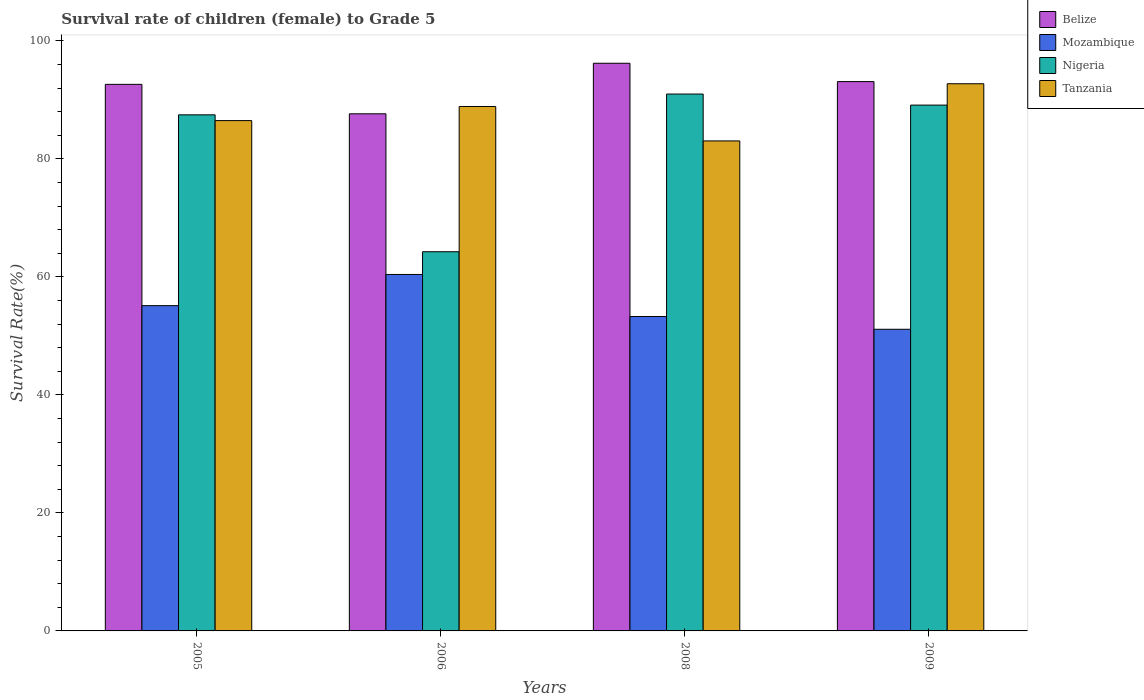How many different coloured bars are there?
Keep it short and to the point. 4. How many groups of bars are there?
Offer a terse response. 4. Are the number of bars per tick equal to the number of legend labels?
Provide a succinct answer. Yes. Are the number of bars on each tick of the X-axis equal?
Provide a succinct answer. Yes. What is the label of the 1st group of bars from the left?
Ensure brevity in your answer.  2005. What is the survival rate of female children to grade 5 in Mozambique in 2006?
Provide a short and direct response. 60.4. Across all years, what is the maximum survival rate of female children to grade 5 in Belize?
Your response must be concise. 96.19. Across all years, what is the minimum survival rate of female children to grade 5 in Belize?
Make the answer very short. 87.63. What is the total survival rate of female children to grade 5 in Mozambique in the graph?
Your answer should be very brief. 219.91. What is the difference between the survival rate of female children to grade 5 in Belize in 2006 and that in 2008?
Offer a very short reply. -8.56. What is the difference between the survival rate of female children to grade 5 in Mozambique in 2008 and the survival rate of female children to grade 5 in Belize in 2009?
Offer a very short reply. -39.81. What is the average survival rate of female children to grade 5 in Mozambique per year?
Offer a terse response. 54.98. In the year 2006, what is the difference between the survival rate of female children to grade 5 in Belize and survival rate of female children to grade 5 in Nigeria?
Offer a terse response. 23.38. What is the ratio of the survival rate of female children to grade 5 in Belize in 2006 to that in 2009?
Give a very brief answer. 0.94. Is the survival rate of female children to grade 5 in Tanzania in 2008 less than that in 2009?
Offer a terse response. Yes. What is the difference between the highest and the second highest survival rate of female children to grade 5 in Nigeria?
Give a very brief answer. 1.87. What is the difference between the highest and the lowest survival rate of female children to grade 5 in Tanzania?
Ensure brevity in your answer.  9.69. Is the sum of the survival rate of female children to grade 5 in Mozambique in 2005 and 2006 greater than the maximum survival rate of female children to grade 5 in Tanzania across all years?
Your answer should be very brief. Yes. Is it the case that in every year, the sum of the survival rate of female children to grade 5 in Mozambique and survival rate of female children to grade 5 in Tanzania is greater than the sum of survival rate of female children to grade 5 in Belize and survival rate of female children to grade 5 in Nigeria?
Your response must be concise. No. What does the 4th bar from the left in 2006 represents?
Provide a succinct answer. Tanzania. What does the 2nd bar from the right in 2008 represents?
Your answer should be compact. Nigeria. Are all the bars in the graph horizontal?
Keep it short and to the point. No. How many years are there in the graph?
Your answer should be very brief. 4. What is the difference between two consecutive major ticks on the Y-axis?
Make the answer very short. 20. Are the values on the major ticks of Y-axis written in scientific E-notation?
Offer a very short reply. No. Does the graph contain any zero values?
Your response must be concise. No. Does the graph contain grids?
Offer a terse response. No. Where does the legend appear in the graph?
Provide a succinct answer. Top right. How many legend labels are there?
Your response must be concise. 4. What is the title of the graph?
Give a very brief answer. Survival rate of children (female) to Grade 5. What is the label or title of the X-axis?
Your answer should be very brief. Years. What is the label or title of the Y-axis?
Your response must be concise. Survival Rate(%). What is the Survival Rate(%) of Belize in 2005?
Your answer should be very brief. 92.62. What is the Survival Rate(%) in Mozambique in 2005?
Your answer should be compact. 55.12. What is the Survival Rate(%) in Nigeria in 2005?
Provide a short and direct response. 87.45. What is the Survival Rate(%) of Tanzania in 2005?
Make the answer very short. 86.48. What is the Survival Rate(%) in Belize in 2006?
Make the answer very short. 87.63. What is the Survival Rate(%) of Mozambique in 2006?
Your answer should be compact. 60.4. What is the Survival Rate(%) of Nigeria in 2006?
Your answer should be compact. 64.25. What is the Survival Rate(%) in Tanzania in 2006?
Give a very brief answer. 88.87. What is the Survival Rate(%) of Belize in 2008?
Your answer should be compact. 96.19. What is the Survival Rate(%) in Mozambique in 2008?
Keep it short and to the point. 53.28. What is the Survival Rate(%) of Nigeria in 2008?
Make the answer very short. 90.98. What is the Survival Rate(%) of Tanzania in 2008?
Provide a short and direct response. 83.03. What is the Survival Rate(%) of Belize in 2009?
Make the answer very short. 93.09. What is the Survival Rate(%) in Mozambique in 2009?
Offer a very short reply. 51.12. What is the Survival Rate(%) in Nigeria in 2009?
Offer a very short reply. 89.1. What is the Survival Rate(%) in Tanzania in 2009?
Offer a terse response. 92.72. Across all years, what is the maximum Survival Rate(%) of Belize?
Provide a succinct answer. 96.19. Across all years, what is the maximum Survival Rate(%) of Mozambique?
Give a very brief answer. 60.4. Across all years, what is the maximum Survival Rate(%) of Nigeria?
Provide a short and direct response. 90.98. Across all years, what is the maximum Survival Rate(%) of Tanzania?
Keep it short and to the point. 92.72. Across all years, what is the minimum Survival Rate(%) of Belize?
Ensure brevity in your answer.  87.63. Across all years, what is the minimum Survival Rate(%) of Mozambique?
Give a very brief answer. 51.12. Across all years, what is the minimum Survival Rate(%) in Nigeria?
Offer a terse response. 64.25. Across all years, what is the minimum Survival Rate(%) of Tanzania?
Give a very brief answer. 83.03. What is the total Survival Rate(%) of Belize in the graph?
Offer a terse response. 369.53. What is the total Survival Rate(%) in Mozambique in the graph?
Provide a succinct answer. 219.91. What is the total Survival Rate(%) in Nigeria in the graph?
Provide a short and direct response. 331.79. What is the total Survival Rate(%) in Tanzania in the graph?
Your answer should be compact. 351.1. What is the difference between the Survival Rate(%) in Belize in 2005 and that in 2006?
Offer a terse response. 4.99. What is the difference between the Survival Rate(%) in Mozambique in 2005 and that in 2006?
Make the answer very short. -5.28. What is the difference between the Survival Rate(%) in Nigeria in 2005 and that in 2006?
Your answer should be compact. 23.2. What is the difference between the Survival Rate(%) in Tanzania in 2005 and that in 2006?
Your response must be concise. -2.39. What is the difference between the Survival Rate(%) in Belize in 2005 and that in 2008?
Offer a very short reply. -3.58. What is the difference between the Survival Rate(%) of Mozambique in 2005 and that in 2008?
Your answer should be very brief. 1.84. What is the difference between the Survival Rate(%) of Nigeria in 2005 and that in 2008?
Give a very brief answer. -3.52. What is the difference between the Survival Rate(%) in Tanzania in 2005 and that in 2008?
Offer a terse response. 3.44. What is the difference between the Survival Rate(%) in Belize in 2005 and that in 2009?
Offer a very short reply. -0.47. What is the difference between the Survival Rate(%) of Mozambique in 2005 and that in 2009?
Your answer should be very brief. 4. What is the difference between the Survival Rate(%) in Nigeria in 2005 and that in 2009?
Ensure brevity in your answer.  -1.65. What is the difference between the Survival Rate(%) of Tanzania in 2005 and that in 2009?
Offer a terse response. -6.25. What is the difference between the Survival Rate(%) in Belize in 2006 and that in 2008?
Keep it short and to the point. -8.56. What is the difference between the Survival Rate(%) in Mozambique in 2006 and that in 2008?
Offer a very short reply. 7.13. What is the difference between the Survival Rate(%) of Nigeria in 2006 and that in 2008?
Make the answer very short. -26.72. What is the difference between the Survival Rate(%) of Tanzania in 2006 and that in 2008?
Your answer should be compact. 5.83. What is the difference between the Survival Rate(%) of Belize in 2006 and that in 2009?
Offer a very short reply. -5.46. What is the difference between the Survival Rate(%) in Mozambique in 2006 and that in 2009?
Keep it short and to the point. 9.29. What is the difference between the Survival Rate(%) of Nigeria in 2006 and that in 2009?
Make the answer very short. -24.85. What is the difference between the Survival Rate(%) of Tanzania in 2006 and that in 2009?
Your response must be concise. -3.86. What is the difference between the Survival Rate(%) in Belize in 2008 and that in 2009?
Offer a terse response. 3.11. What is the difference between the Survival Rate(%) in Mozambique in 2008 and that in 2009?
Your answer should be very brief. 2.16. What is the difference between the Survival Rate(%) of Nigeria in 2008 and that in 2009?
Offer a very short reply. 1.87. What is the difference between the Survival Rate(%) of Tanzania in 2008 and that in 2009?
Give a very brief answer. -9.69. What is the difference between the Survival Rate(%) in Belize in 2005 and the Survival Rate(%) in Mozambique in 2006?
Offer a very short reply. 32.22. What is the difference between the Survival Rate(%) of Belize in 2005 and the Survival Rate(%) of Nigeria in 2006?
Provide a succinct answer. 28.37. What is the difference between the Survival Rate(%) in Belize in 2005 and the Survival Rate(%) in Tanzania in 2006?
Offer a very short reply. 3.75. What is the difference between the Survival Rate(%) in Mozambique in 2005 and the Survival Rate(%) in Nigeria in 2006?
Give a very brief answer. -9.13. What is the difference between the Survival Rate(%) in Mozambique in 2005 and the Survival Rate(%) in Tanzania in 2006?
Give a very brief answer. -33.75. What is the difference between the Survival Rate(%) in Nigeria in 2005 and the Survival Rate(%) in Tanzania in 2006?
Offer a very short reply. -1.41. What is the difference between the Survival Rate(%) of Belize in 2005 and the Survival Rate(%) of Mozambique in 2008?
Provide a succinct answer. 39.34. What is the difference between the Survival Rate(%) in Belize in 2005 and the Survival Rate(%) in Nigeria in 2008?
Offer a very short reply. 1.64. What is the difference between the Survival Rate(%) of Belize in 2005 and the Survival Rate(%) of Tanzania in 2008?
Offer a very short reply. 9.59. What is the difference between the Survival Rate(%) of Mozambique in 2005 and the Survival Rate(%) of Nigeria in 2008?
Ensure brevity in your answer.  -35.86. What is the difference between the Survival Rate(%) in Mozambique in 2005 and the Survival Rate(%) in Tanzania in 2008?
Your answer should be very brief. -27.91. What is the difference between the Survival Rate(%) of Nigeria in 2005 and the Survival Rate(%) of Tanzania in 2008?
Your answer should be compact. 4.42. What is the difference between the Survival Rate(%) of Belize in 2005 and the Survival Rate(%) of Mozambique in 2009?
Your answer should be very brief. 41.5. What is the difference between the Survival Rate(%) in Belize in 2005 and the Survival Rate(%) in Nigeria in 2009?
Your response must be concise. 3.52. What is the difference between the Survival Rate(%) in Belize in 2005 and the Survival Rate(%) in Tanzania in 2009?
Your response must be concise. -0.1. What is the difference between the Survival Rate(%) of Mozambique in 2005 and the Survival Rate(%) of Nigeria in 2009?
Offer a terse response. -33.98. What is the difference between the Survival Rate(%) in Mozambique in 2005 and the Survival Rate(%) in Tanzania in 2009?
Make the answer very short. -37.6. What is the difference between the Survival Rate(%) in Nigeria in 2005 and the Survival Rate(%) in Tanzania in 2009?
Make the answer very short. -5.27. What is the difference between the Survival Rate(%) in Belize in 2006 and the Survival Rate(%) in Mozambique in 2008?
Keep it short and to the point. 34.35. What is the difference between the Survival Rate(%) in Belize in 2006 and the Survival Rate(%) in Nigeria in 2008?
Provide a succinct answer. -3.35. What is the difference between the Survival Rate(%) in Belize in 2006 and the Survival Rate(%) in Tanzania in 2008?
Offer a very short reply. 4.6. What is the difference between the Survival Rate(%) in Mozambique in 2006 and the Survival Rate(%) in Nigeria in 2008?
Provide a short and direct response. -30.57. What is the difference between the Survival Rate(%) of Mozambique in 2006 and the Survival Rate(%) of Tanzania in 2008?
Your answer should be compact. -22.63. What is the difference between the Survival Rate(%) in Nigeria in 2006 and the Survival Rate(%) in Tanzania in 2008?
Keep it short and to the point. -18.78. What is the difference between the Survival Rate(%) in Belize in 2006 and the Survival Rate(%) in Mozambique in 2009?
Offer a very short reply. 36.51. What is the difference between the Survival Rate(%) of Belize in 2006 and the Survival Rate(%) of Nigeria in 2009?
Ensure brevity in your answer.  -1.47. What is the difference between the Survival Rate(%) of Belize in 2006 and the Survival Rate(%) of Tanzania in 2009?
Offer a very short reply. -5.09. What is the difference between the Survival Rate(%) of Mozambique in 2006 and the Survival Rate(%) of Nigeria in 2009?
Ensure brevity in your answer.  -28.7. What is the difference between the Survival Rate(%) of Mozambique in 2006 and the Survival Rate(%) of Tanzania in 2009?
Ensure brevity in your answer.  -32.32. What is the difference between the Survival Rate(%) of Nigeria in 2006 and the Survival Rate(%) of Tanzania in 2009?
Offer a very short reply. -28.47. What is the difference between the Survival Rate(%) in Belize in 2008 and the Survival Rate(%) in Mozambique in 2009?
Make the answer very short. 45.08. What is the difference between the Survival Rate(%) in Belize in 2008 and the Survival Rate(%) in Nigeria in 2009?
Offer a terse response. 7.09. What is the difference between the Survival Rate(%) of Belize in 2008 and the Survival Rate(%) of Tanzania in 2009?
Your response must be concise. 3.47. What is the difference between the Survival Rate(%) of Mozambique in 2008 and the Survival Rate(%) of Nigeria in 2009?
Give a very brief answer. -35.83. What is the difference between the Survival Rate(%) in Mozambique in 2008 and the Survival Rate(%) in Tanzania in 2009?
Offer a terse response. -39.45. What is the difference between the Survival Rate(%) in Nigeria in 2008 and the Survival Rate(%) in Tanzania in 2009?
Offer a terse response. -1.75. What is the average Survival Rate(%) in Belize per year?
Offer a terse response. 92.38. What is the average Survival Rate(%) of Mozambique per year?
Your response must be concise. 54.98. What is the average Survival Rate(%) of Nigeria per year?
Make the answer very short. 82.95. What is the average Survival Rate(%) of Tanzania per year?
Keep it short and to the point. 87.78. In the year 2005, what is the difference between the Survival Rate(%) of Belize and Survival Rate(%) of Mozambique?
Your answer should be compact. 37.5. In the year 2005, what is the difference between the Survival Rate(%) of Belize and Survival Rate(%) of Nigeria?
Offer a very short reply. 5.17. In the year 2005, what is the difference between the Survival Rate(%) in Belize and Survival Rate(%) in Tanzania?
Ensure brevity in your answer.  6.14. In the year 2005, what is the difference between the Survival Rate(%) in Mozambique and Survival Rate(%) in Nigeria?
Provide a succinct answer. -32.33. In the year 2005, what is the difference between the Survival Rate(%) in Mozambique and Survival Rate(%) in Tanzania?
Give a very brief answer. -31.36. In the year 2005, what is the difference between the Survival Rate(%) of Nigeria and Survival Rate(%) of Tanzania?
Ensure brevity in your answer.  0.98. In the year 2006, what is the difference between the Survival Rate(%) in Belize and Survival Rate(%) in Mozambique?
Provide a succinct answer. 27.23. In the year 2006, what is the difference between the Survival Rate(%) of Belize and Survival Rate(%) of Nigeria?
Provide a short and direct response. 23.38. In the year 2006, what is the difference between the Survival Rate(%) of Belize and Survival Rate(%) of Tanzania?
Give a very brief answer. -1.24. In the year 2006, what is the difference between the Survival Rate(%) of Mozambique and Survival Rate(%) of Nigeria?
Ensure brevity in your answer.  -3.85. In the year 2006, what is the difference between the Survival Rate(%) in Mozambique and Survival Rate(%) in Tanzania?
Make the answer very short. -28.46. In the year 2006, what is the difference between the Survival Rate(%) in Nigeria and Survival Rate(%) in Tanzania?
Keep it short and to the point. -24.61. In the year 2008, what is the difference between the Survival Rate(%) in Belize and Survival Rate(%) in Mozambique?
Offer a very short reply. 42.92. In the year 2008, what is the difference between the Survival Rate(%) in Belize and Survival Rate(%) in Nigeria?
Your answer should be compact. 5.22. In the year 2008, what is the difference between the Survival Rate(%) in Belize and Survival Rate(%) in Tanzania?
Give a very brief answer. 13.16. In the year 2008, what is the difference between the Survival Rate(%) of Mozambique and Survival Rate(%) of Nigeria?
Your answer should be compact. -37.7. In the year 2008, what is the difference between the Survival Rate(%) in Mozambique and Survival Rate(%) in Tanzania?
Ensure brevity in your answer.  -29.76. In the year 2008, what is the difference between the Survival Rate(%) of Nigeria and Survival Rate(%) of Tanzania?
Offer a terse response. 7.94. In the year 2009, what is the difference between the Survival Rate(%) in Belize and Survival Rate(%) in Mozambique?
Provide a short and direct response. 41.97. In the year 2009, what is the difference between the Survival Rate(%) in Belize and Survival Rate(%) in Nigeria?
Offer a terse response. 3.98. In the year 2009, what is the difference between the Survival Rate(%) of Belize and Survival Rate(%) of Tanzania?
Offer a very short reply. 0.36. In the year 2009, what is the difference between the Survival Rate(%) in Mozambique and Survival Rate(%) in Nigeria?
Offer a terse response. -37.99. In the year 2009, what is the difference between the Survival Rate(%) of Mozambique and Survival Rate(%) of Tanzania?
Provide a short and direct response. -41.61. In the year 2009, what is the difference between the Survival Rate(%) in Nigeria and Survival Rate(%) in Tanzania?
Your answer should be compact. -3.62. What is the ratio of the Survival Rate(%) of Belize in 2005 to that in 2006?
Your answer should be compact. 1.06. What is the ratio of the Survival Rate(%) in Mozambique in 2005 to that in 2006?
Your answer should be compact. 0.91. What is the ratio of the Survival Rate(%) in Nigeria in 2005 to that in 2006?
Offer a very short reply. 1.36. What is the ratio of the Survival Rate(%) of Tanzania in 2005 to that in 2006?
Your answer should be compact. 0.97. What is the ratio of the Survival Rate(%) of Belize in 2005 to that in 2008?
Your answer should be very brief. 0.96. What is the ratio of the Survival Rate(%) of Mozambique in 2005 to that in 2008?
Make the answer very short. 1.03. What is the ratio of the Survival Rate(%) of Nigeria in 2005 to that in 2008?
Offer a very short reply. 0.96. What is the ratio of the Survival Rate(%) in Tanzania in 2005 to that in 2008?
Keep it short and to the point. 1.04. What is the ratio of the Survival Rate(%) in Belize in 2005 to that in 2009?
Ensure brevity in your answer.  0.99. What is the ratio of the Survival Rate(%) of Mozambique in 2005 to that in 2009?
Make the answer very short. 1.08. What is the ratio of the Survival Rate(%) of Nigeria in 2005 to that in 2009?
Give a very brief answer. 0.98. What is the ratio of the Survival Rate(%) of Tanzania in 2005 to that in 2009?
Provide a short and direct response. 0.93. What is the ratio of the Survival Rate(%) in Belize in 2006 to that in 2008?
Give a very brief answer. 0.91. What is the ratio of the Survival Rate(%) in Mozambique in 2006 to that in 2008?
Provide a succinct answer. 1.13. What is the ratio of the Survival Rate(%) in Nigeria in 2006 to that in 2008?
Provide a succinct answer. 0.71. What is the ratio of the Survival Rate(%) in Tanzania in 2006 to that in 2008?
Your response must be concise. 1.07. What is the ratio of the Survival Rate(%) of Belize in 2006 to that in 2009?
Give a very brief answer. 0.94. What is the ratio of the Survival Rate(%) in Mozambique in 2006 to that in 2009?
Ensure brevity in your answer.  1.18. What is the ratio of the Survival Rate(%) of Nigeria in 2006 to that in 2009?
Keep it short and to the point. 0.72. What is the ratio of the Survival Rate(%) of Tanzania in 2006 to that in 2009?
Offer a terse response. 0.96. What is the ratio of the Survival Rate(%) of Belize in 2008 to that in 2009?
Ensure brevity in your answer.  1.03. What is the ratio of the Survival Rate(%) in Mozambique in 2008 to that in 2009?
Keep it short and to the point. 1.04. What is the ratio of the Survival Rate(%) in Nigeria in 2008 to that in 2009?
Provide a short and direct response. 1.02. What is the ratio of the Survival Rate(%) in Tanzania in 2008 to that in 2009?
Offer a very short reply. 0.9. What is the difference between the highest and the second highest Survival Rate(%) in Belize?
Provide a succinct answer. 3.11. What is the difference between the highest and the second highest Survival Rate(%) of Mozambique?
Provide a succinct answer. 5.28. What is the difference between the highest and the second highest Survival Rate(%) in Nigeria?
Your response must be concise. 1.87. What is the difference between the highest and the second highest Survival Rate(%) of Tanzania?
Give a very brief answer. 3.86. What is the difference between the highest and the lowest Survival Rate(%) of Belize?
Provide a short and direct response. 8.56. What is the difference between the highest and the lowest Survival Rate(%) of Mozambique?
Your answer should be very brief. 9.29. What is the difference between the highest and the lowest Survival Rate(%) in Nigeria?
Ensure brevity in your answer.  26.72. What is the difference between the highest and the lowest Survival Rate(%) in Tanzania?
Offer a terse response. 9.69. 